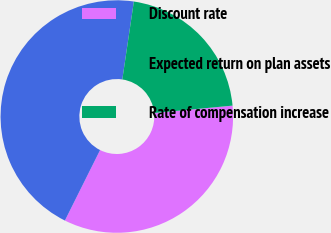<chart> <loc_0><loc_0><loc_500><loc_500><pie_chart><fcel>Discount rate<fcel>Expected return on plan assets<fcel>Rate of compensation increase<nl><fcel>33.86%<fcel>44.97%<fcel>21.16%<nl></chart> 